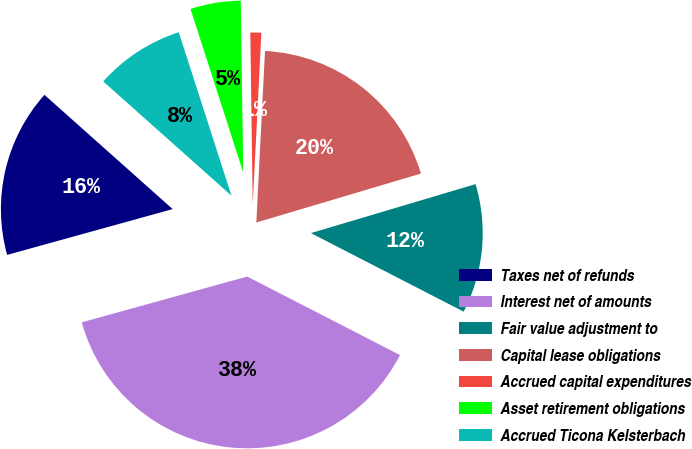<chart> <loc_0><loc_0><loc_500><loc_500><pie_chart><fcel>Taxes net of refunds<fcel>Interest net of amounts<fcel>Fair value adjustment to<fcel>Capital lease obligations<fcel>Accrued capital expenditures<fcel>Asset retirement obligations<fcel>Accrued Ticona Kelsterbach<nl><fcel>15.88%<fcel>38.14%<fcel>12.16%<fcel>19.59%<fcel>1.03%<fcel>4.74%<fcel>8.45%<nl></chart> 